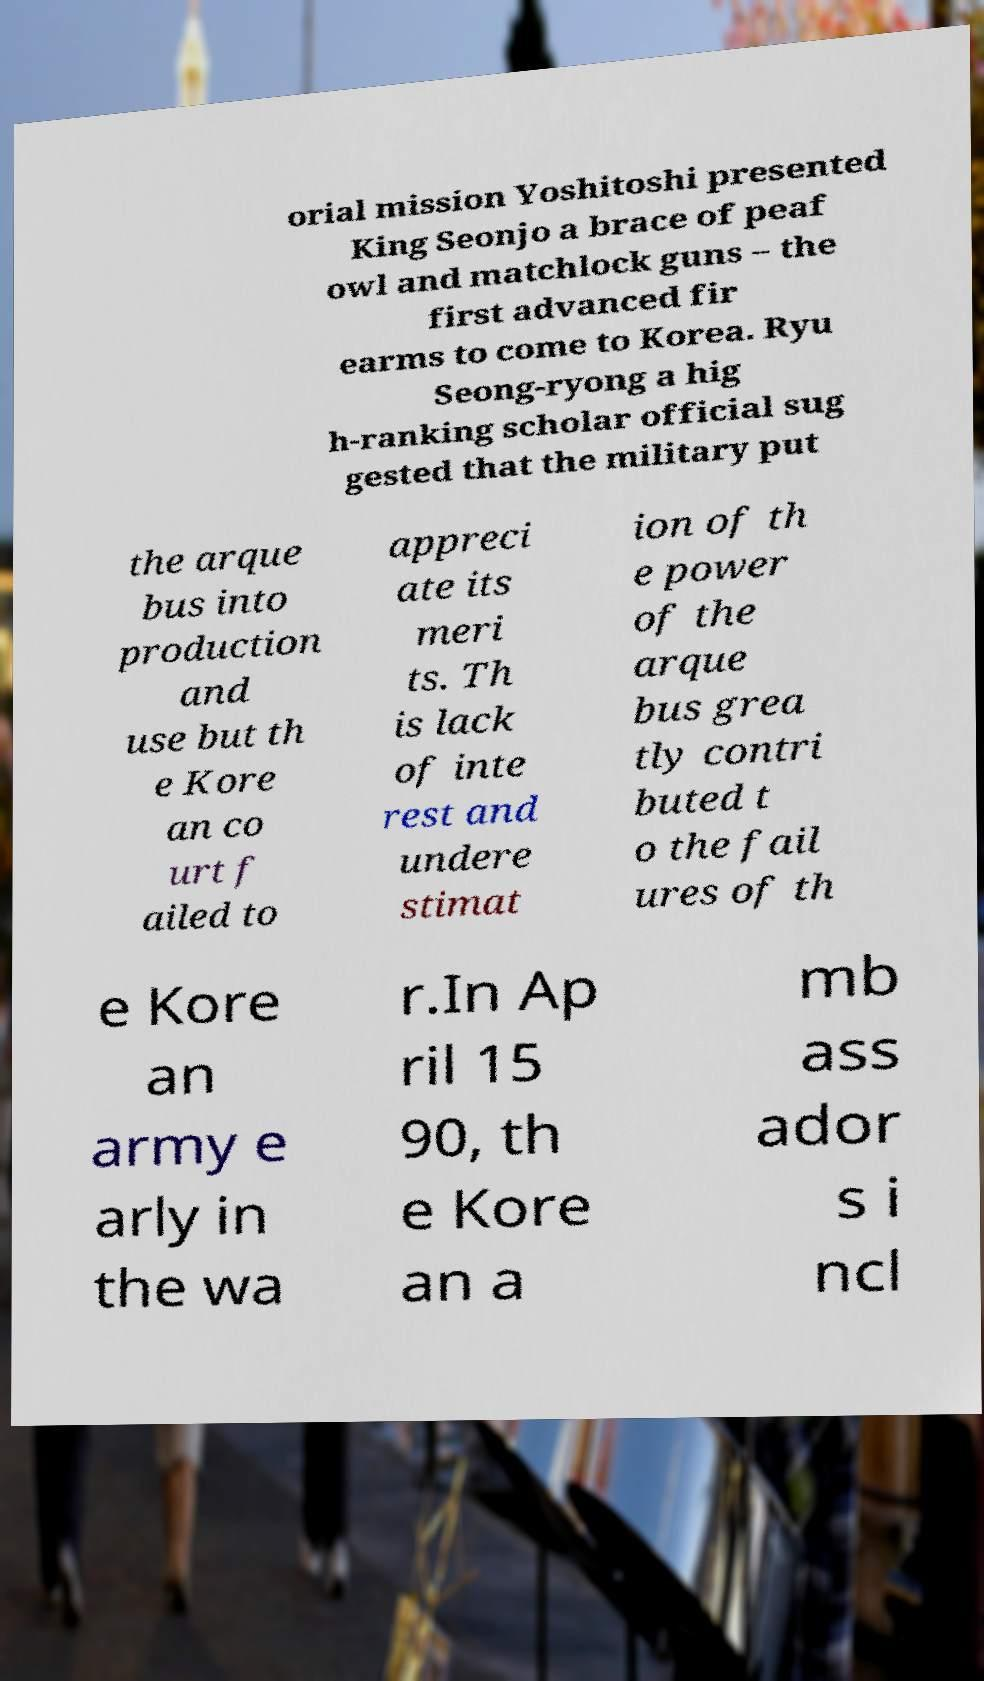Please read and relay the text visible in this image. What does it say? orial mission Yoshitoshi presented King Seonjo a brace of peaf owl and matchlock guns – the first advanced fir earms to come to Korea. Ryu Seong-ryong a hig h-ranking scholar official sug gested that the military put the arque bus into production and use but th e Kore an co urt f ailed to appreci ate its meri ts. Th is lack of inte rest and undere stimat ion of th e power of the arque bus grea tly contri buted t o the fail ures of th e Kore an army e arly in the wa r.In Ap ril 15 90, th e Kore an a mb ass ador s i ncl 